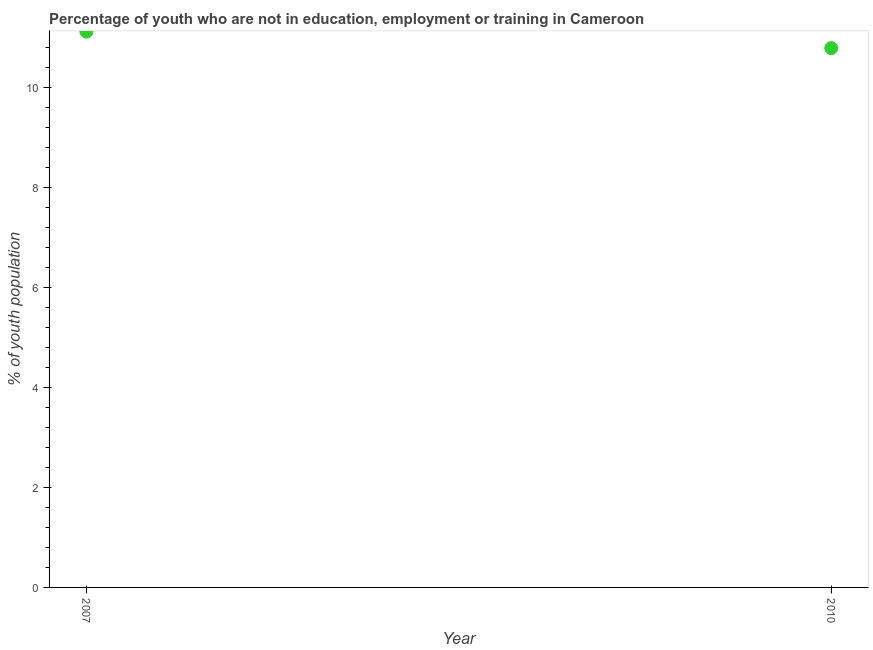What is the unemployed youth population in 2007?
Give a very brief answer. 11.12. Across all years, what is the maximum unemployed youth population?
Your answer should be very brief. 11.12. Across all years, what is the minimum unemployed youth population?
Provide a succinct answer. 10.79. In which year was the unemployed youth population maximum?
Offer a terse response. 2007. What is the sum of the unemployed youth population?
Make the answer very short. 21.91. What is the difference between the unemployed youth population in 2007 and 2010?
Provide a short and direct response. 0.33. What is the average unemployed youth population per year?
Your answer should be compact. 10.95. What is the median unemployed youth population?
Ensure brevity in your answer.  10.95. In how many years, is the unemployed youth population greater than 4.8 %?
Ensure brevity in your answer.  2. Do a majority of the years between 2007 and 2010 (inclusive) have unemployed youth population greater than 7.6 %?
Offer a terse response. Yes. What is the ratio of the unemployed youth population in 2007 to that in 2010?
Offer a very short reply. 1.03. Is the unemployed youth population in 2007 less than that in 2010?
Make the answer very short. No. What is the difference between two consecutive major ticks on the Y-axis?
Keep it short and to the point. 2. Does the graph contain grids?
Ensure brevity in your answer.  No. What is the title of the graph?
Offer a terse response. Percentage of youth who are not in education, employment or training in Cameroon. What is the label or title of the X-axis?
Provide a short and direct response. Year. What is the label or title of the Y-axis?
Offer a very short reply. % of youth population. What is the % of youth population in 2007?
Your answer should be very brief. 11.12. What is the % of youth population in 2010?
Provide a short and direct response. 10.79. What is the difference between the % of youth population in 2007 and 2010?
Give a very brief answer. 0.33. What is the ratio of the % of youth population in 2007 to that in 2010?
Your response must be concise. 1.03. 